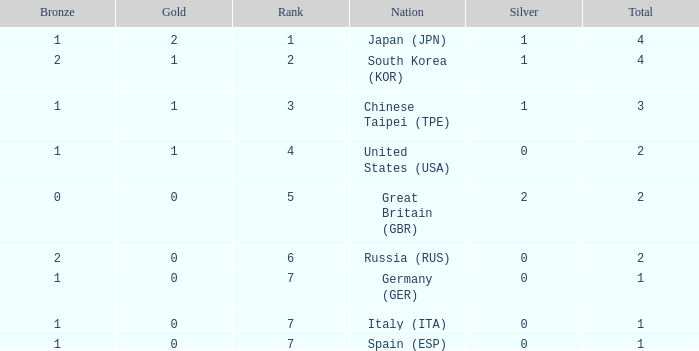What is the smallest number of gold of a country of rank 6, with 2 bronzes? None. Can you give me this table as a dict? {'header': ['Bronze', 'Gold', 'Rank', 'Nation', 'Silver', 'Total'], 'rows': [['1', '2', '1', 'Japan (JPN)', '1', '4'], ['2', '1', '2', 'South Korea (KOR)', '1', '4'], ['1', '1', '3', 'Chinese Taipei (TPE)', '1', '3'], ['1', '1', '4', 'United States (USA)', '0', '2'], ['0', '0', '5', 'Great Britain (GBR)', '2', '2'], ['2', '0', '6', 'Russia (RUS)', '0', '2'], ['1', '0', '7', 'Germany (GER)', '0', '1'], ['1', '0', '7', 'Italy (ITA)', '0', '1'], ['1', '0', '7', 'Spain (ESP)', '0', '1']]} 